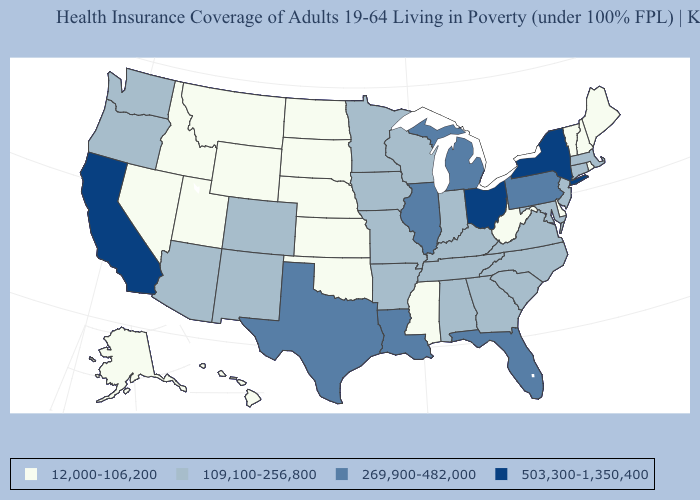Does Iowa have the lowest value in the MidWest?
Be succinct. No. Does Pennsylvania have the same value as Florida?
Concise answer only. Yes. What is the highest value in states that border California?
Concise answer only. 109,100-256,800. Does Nevada have a lower value than Alaska?
Answer briefly. No. What is the value of South Carolina?
Short answer required. 109,100-256,800. Does Virginia have the lowest value in the South?
Give a very brief answer. No. Does Maine have the same value as North Dakota?
Be succinct. Yes. Does Virginia have a lower value than Ohio?
Quick response, please. Yes. What is the lowest value in the South?
Answer briefly. 12,000-106,200. Name the states that have a value in the range 12,000-106,200?
Concise answer only. Alaska, Delaware, Hawaii, Idaho, Kansas, Maine, Mississippi, Montana, Nebraska, Nevada, New Hampshire, North Dakota, Oklahoma, Rhode Island, South Dakota, Utah, Vermont, West Virginia, Wyoming. What is the highest value in the South ?
Concise answer only. 269,900-482,000. Name the states that have a value in the range 503,300-1,350,400?
Be succinct. California, New York, Ohio. Does Alabama have a higher value than Mississippi?
Give a very brief answer. Yes. Among the states that border California , which have the highest value?
Be succinct. Arizona, Oregon. Name the states that have a value in the range 109,100-256,800?
Write a very short answer. Alabama, Arizona, Arkansas, Colorado, Connecticut, Georgia, Indiana, Iowa, Kentucky, Maryland, Massachusetts, Minnesota, Missouri, New Jersey, New Mexico, North Carolina, Oregon, South Carolina, Tennessee, Virginia, Washington, Wisconsin. 